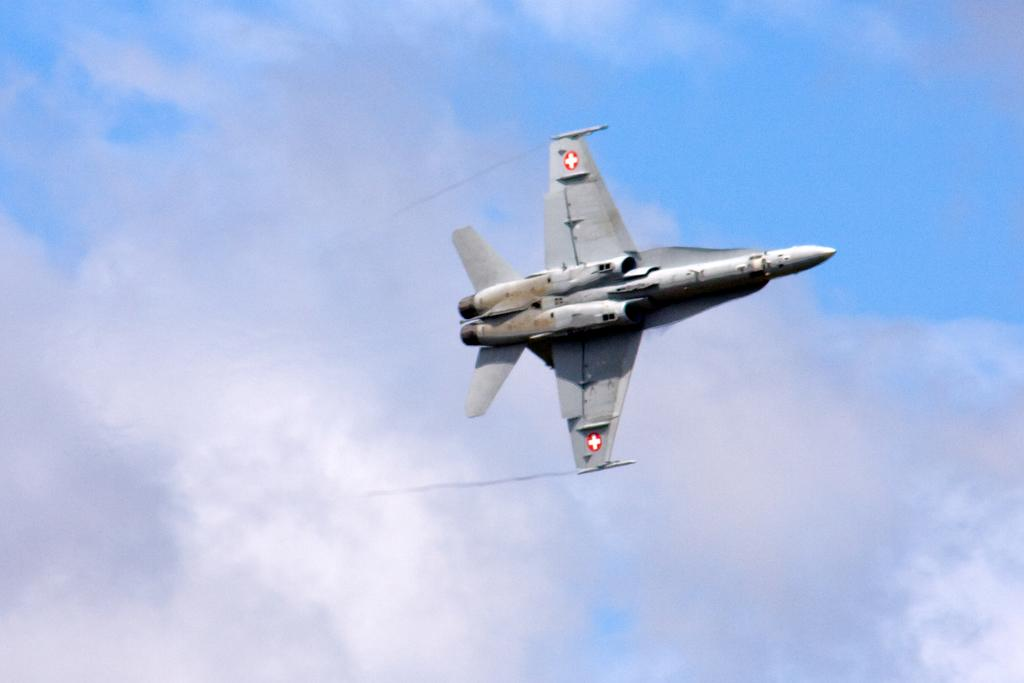What is the main subject of the image? The main subject of the image is a jet plane. What is the jet plane doing in the image? The jet plane is flying in the sky. How would you describe the sky in the image? The sky is filled with clouds. What type of bottle can be seen in the image? There is no bottle present in the image; it features a jet plane flying in the sky with clouds in the background. 